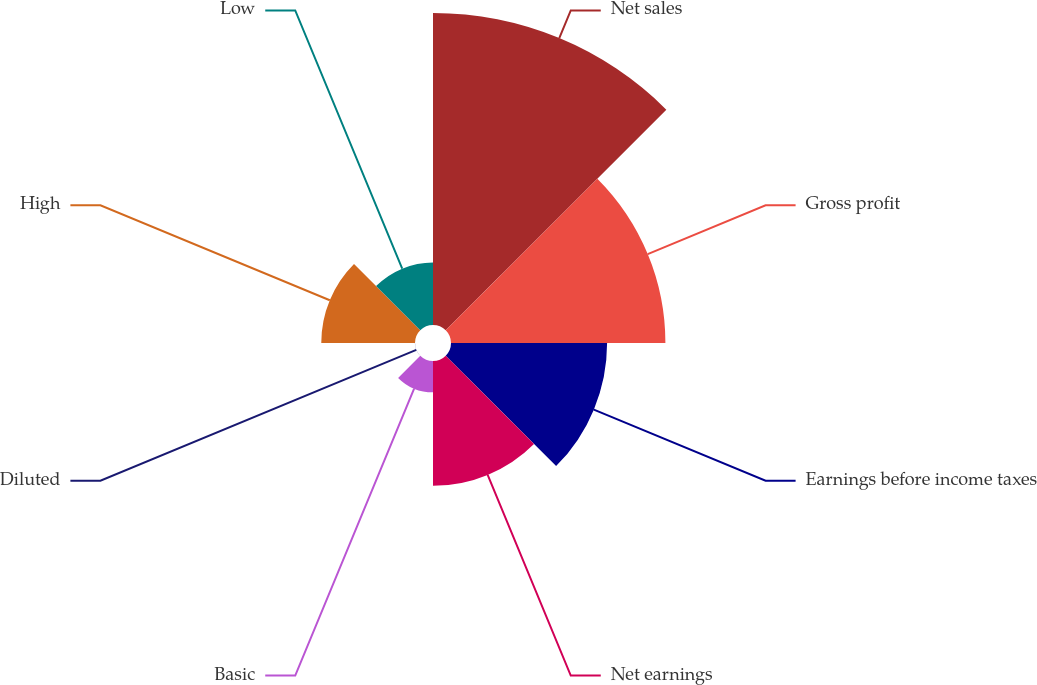<chart> <loc_0><loc_0><loc_500><loc_500><pie_chart><fcel>Net sales<fcel>Gross profit<fcel>Earnings before income taxes<fcel>Net earnings<fcel>Basic<fcel>Diluted<fcel>High<fcel>Low<nl><fcel>31.36%<fcel>21.55%<fcel>15.69%<fcel>12.55%<fcel>3.15%<fcel>0.01%<fcel>9.42%<fcel>6.28%<nl></chart> 